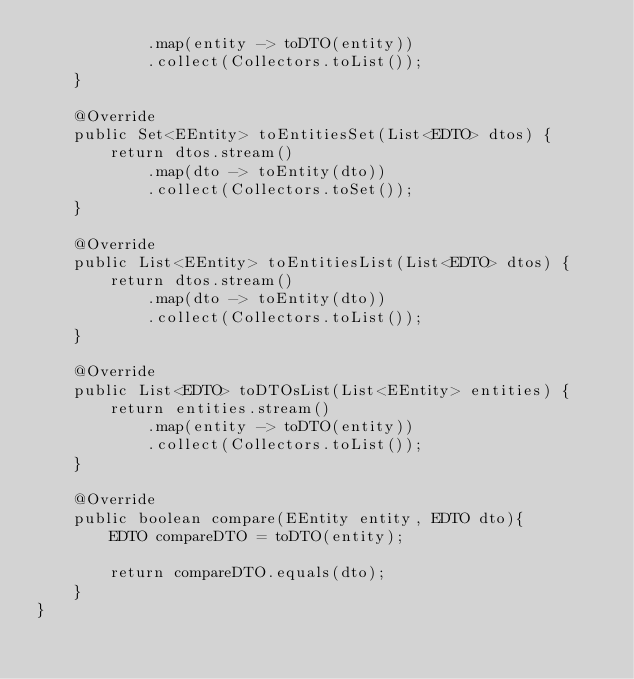<code> <loc_0><loc_0><loc_500><loc_500><_Java_>            .map(entity -> toDTO(entity))
            .collect(Collectors.toList());
    }

    @Override
    public Set<EEntity> toEntitiesSet(List<EDTO> dtos) {
        return dtos.stream()
            .map(dto -> toEntity(dto))
            .collect(Collectors.toSet());
    }

    @Override
    public List<EEntity> toEntitiesList(List<EDTO> dtos) {
        return dtos.stream()
            .map(dto -> toEntity(dto))
            .collect(Collectors.toList());
    }

    @Override
    public List<EDTO> toDTOsList(List<EEntity> entities) {
        return entities.stream()
            .map(entity -> toDTO(entity))
            .collect(Collectors.toList());
    }

    @Override
    public boolean compare(EEntity entity, EDTO dto){
        EDTO compareDTO = toDTO(entity);

        return compareDTO.equals(dto);
    }
}
</code> 